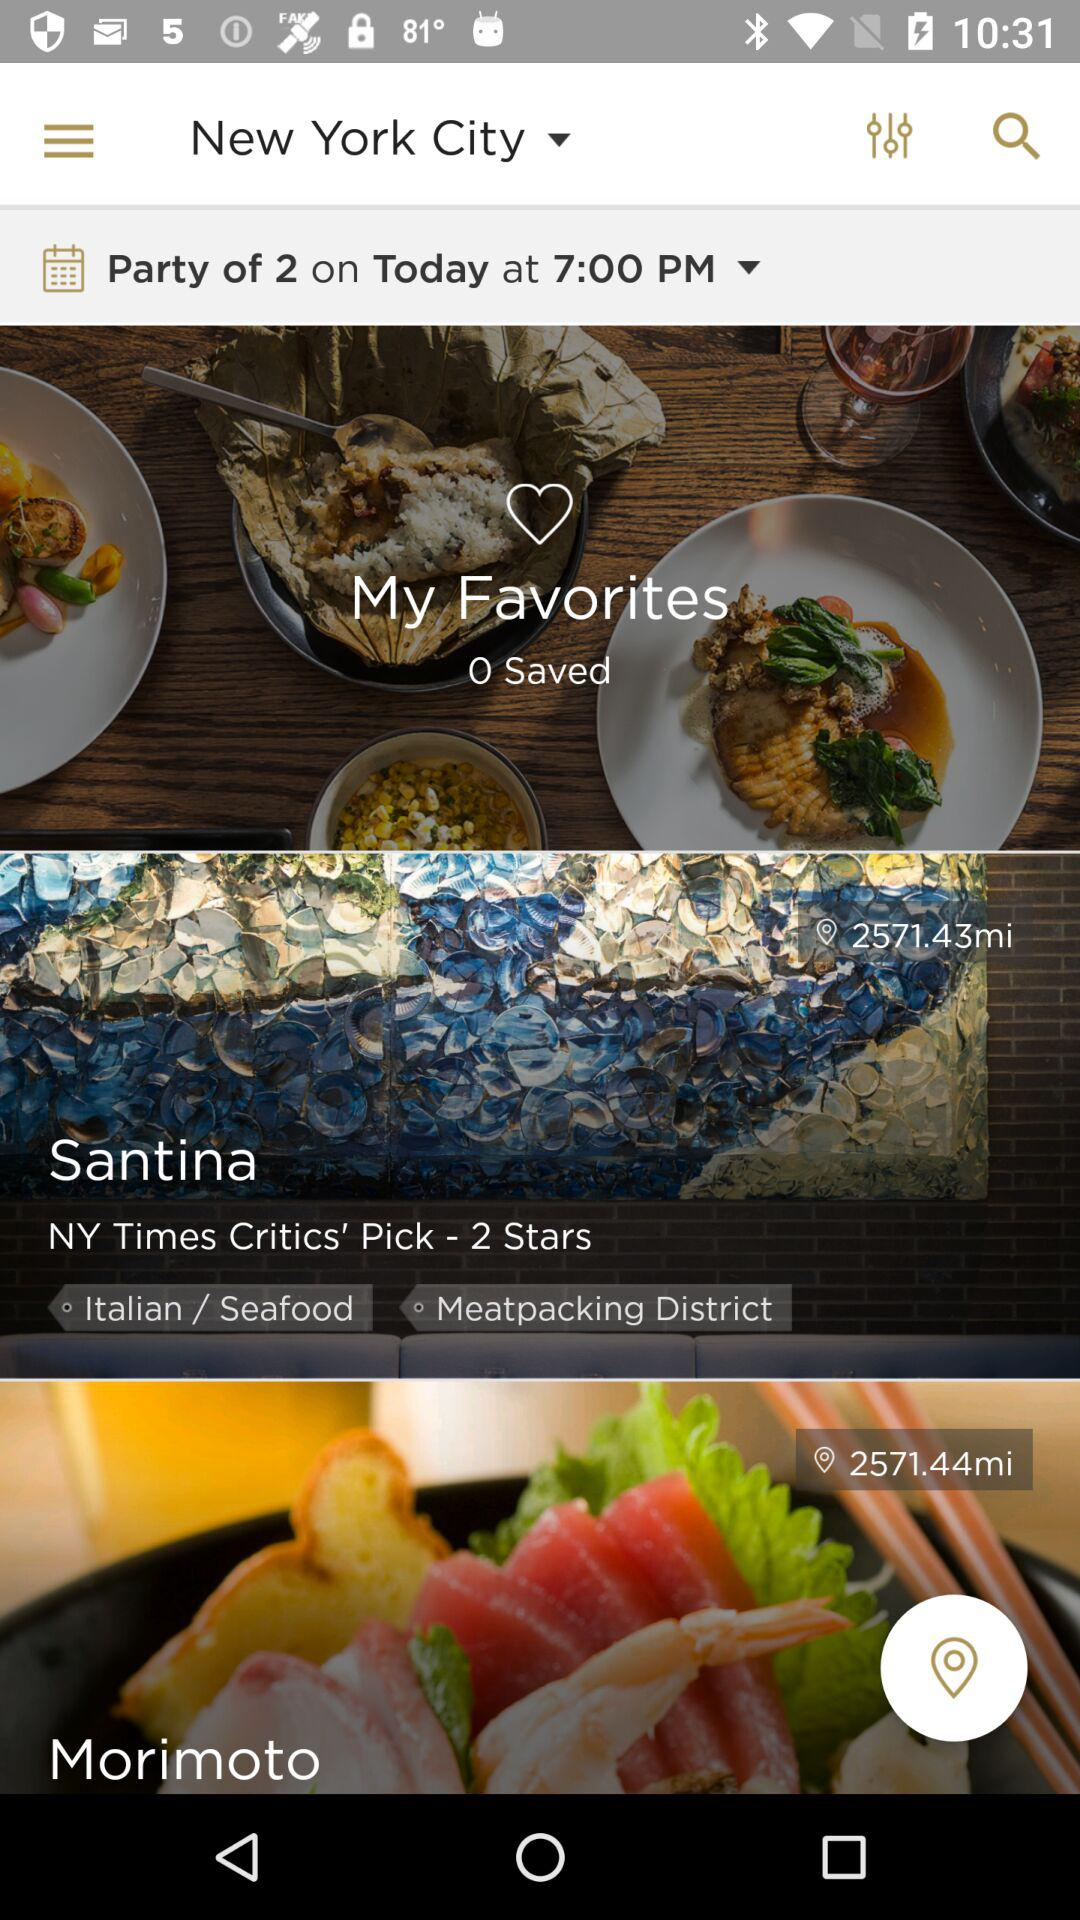How far is Morimoto from my location? Morimoto is 2571.44 miles away from my location. 